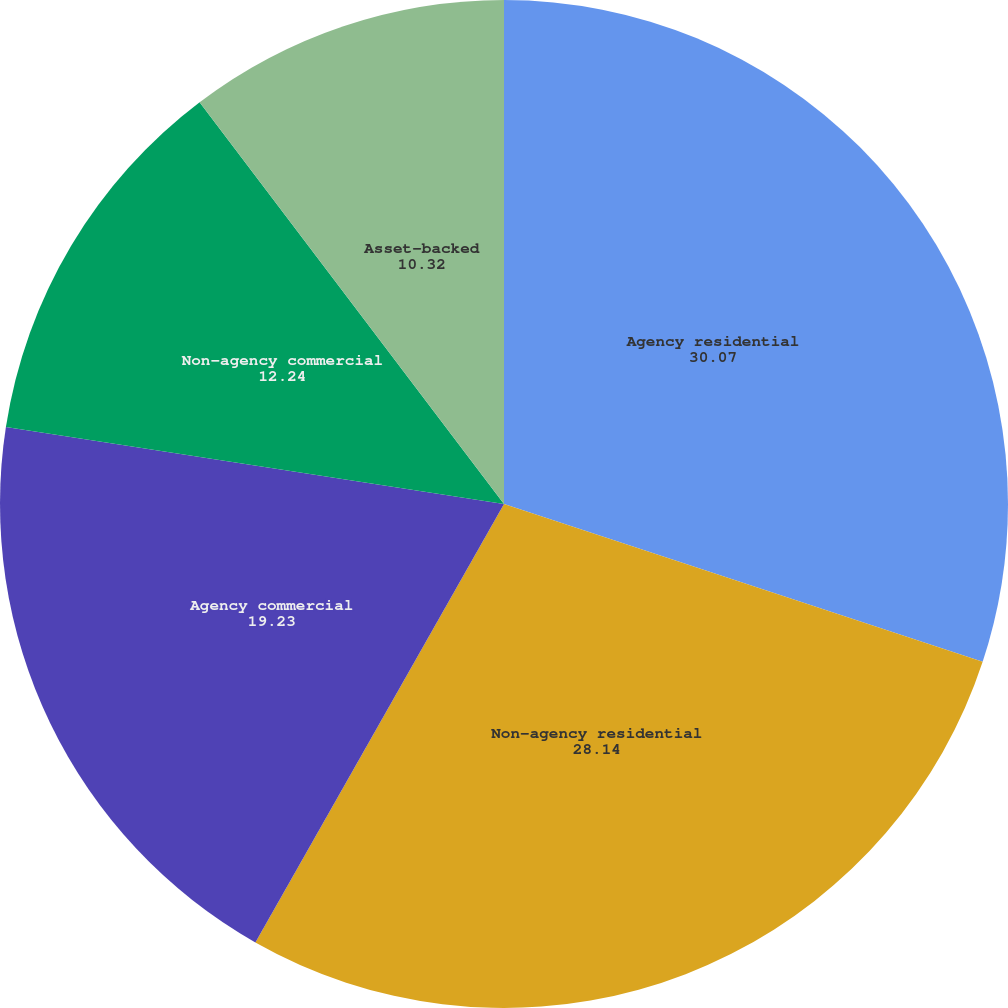<chart> <loc_0><loc_0><loc_500><loc_500><pie_chart><fcel>Agency residential<fcel>Non-agency residential<fcel>Agency commercial<fcel>Non-agency commercial<fcel>Asset-backed<nl><fcel>30.07%<fcel>28.14%<fcel>19.23%<fcel>12.24%<fcel>10.32%<nl></chart> 